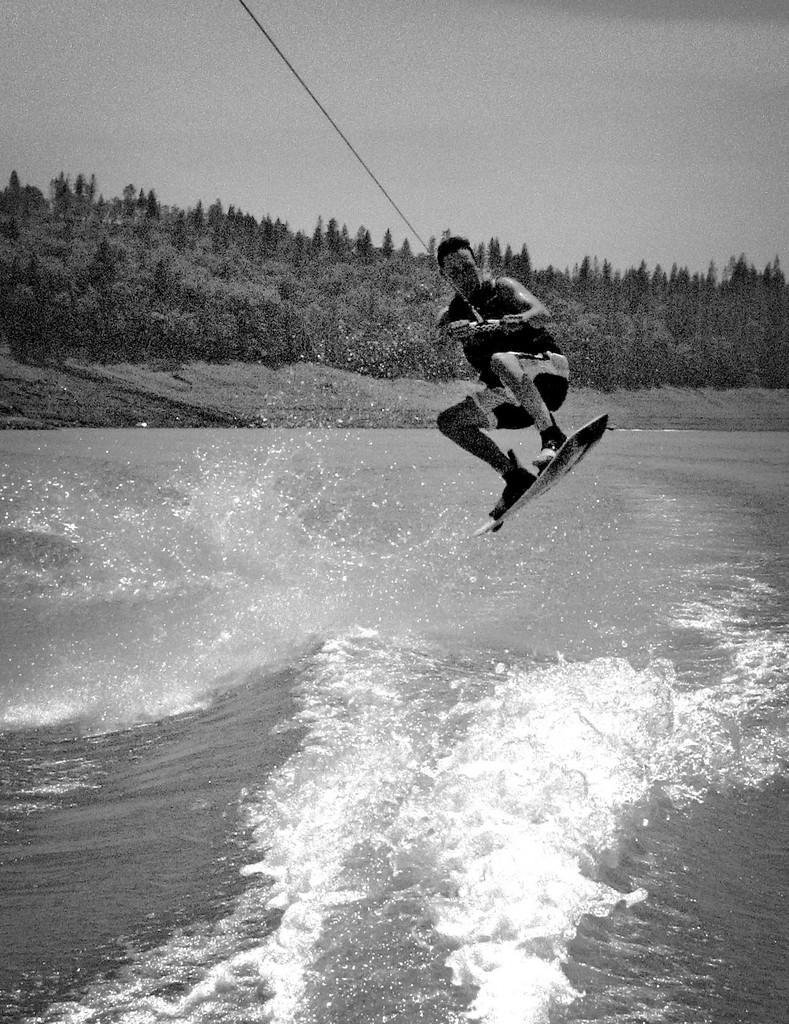Can you describe this image briefly? In the center of the image we can see a person parasailing. At the bottom there is a sea. In the background there are trees and sky. 